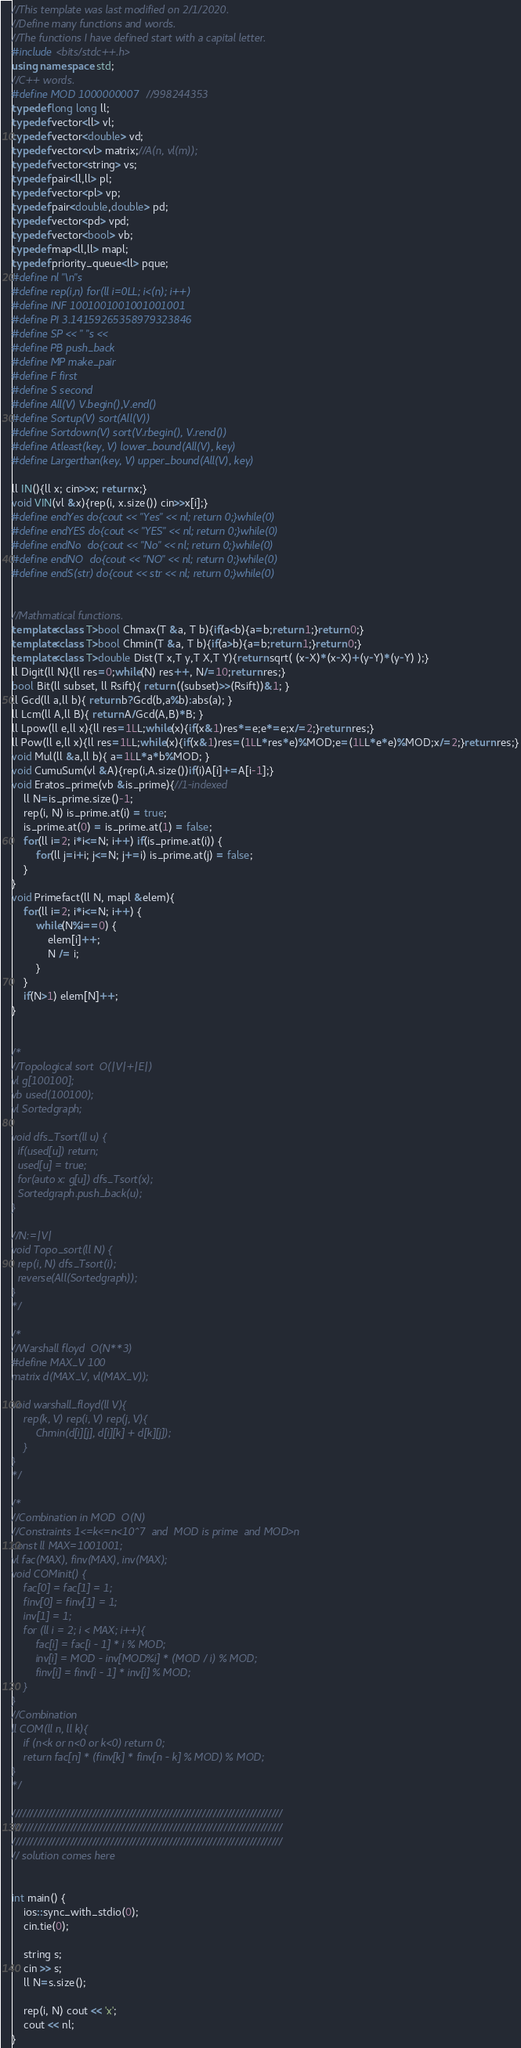<code> <loc_0><loc_0><loc_500><loc_500><_C++_>//This template was last modified on 2/1/2020.
//Define many functions and words.
//The functions I have defined start with a capital letter.
#include <bits/stdc++.h>
using namespace std;
//C++ words.
#define MOD 1000000007 //998244353
typedef long long ll;
typedef vector<ll> vl;
typedef vector<double> vd;
typedef vector<vl> matrix;//A(n, vl(m));
typedef vector<string> vs;
typedef pair<ll,ll> pl;
typedef vector<pl> vp;
typedef pair<double,double> pd;
typedef vector<pd> vpd;
typedef vector<bool> vb;
typedef map<ll,ll> mapl;
typedef priority_queue<ll> pque;
#define nl "\n"s
#define rep(i,n) for(ll i=0LL; i<(n); i++)
#define INF 1001001001001001001
#define PI 3.14159265358979323846
#define SP << " "s <<
#define PB push_back
#define MP make_pair
#define F first
#define S second
#define All(V) V.begin(),V.end()
#define Sortup(V) sort(All(V))
#define Sortdown(V) sort(V.rbegin(), V.rend())
#define Atleast(key, V) lower_bound(All(V), key)
#define Largerthan(key, V) upper_bound(All(V), key)

ll IN(){ll x; cin>>x; return x;}
void VIN(vl &x){rep(i, x.size()) cin>>x[i];}
#define endYes do{cout << "Yes" << nl; return 0;}while(0)
#define endYES do{cout << "YES" << nl; return 0;}while(0)
#define endNo  do{cout << "No" << nl; return 0;}while(0)
#define endNO  do{cout << "NO" << nl; return 0;}while(0)
#define endS(str) do{cout << str << nl; return 0;}while(0)


//Mathmatical functions.
template<class T>bool Chmax(T &a, T b){if(a<b){a=b;return 1;}return 0;}
template<class T>bool Chmin(T &a, T b){if(a>b){a=b;return 1;}return 0;}
template<class T>double Dist(T x,T y,T X,T Y){return sqrt( (x-X)*(x-X)+(y-Y)*(y-Y) );}
ll Digit(ll N){ll res=0;while(N) res++, N/=10;return res;}
bool Bit(ll subset, ll Rsift){ return ((subset)>>(Rsift))&1; }
ll Gcd(ll a,ll b){ return b?Gcd(b,a%b):abs(a); }
ll Lcm(ll A,ll B){ return A/Gcd(A,B)*B; }
ll Lpow(ll e,ll x){ll res=1LL;while(x){if(x&1)res*=e;e*=e;x/=2;}return res;}
ll Pow(ll e,ll x){ll res=1LL;while(x){if(x&1)res=(1LL*res*e)%MOD;e=(1LL*e*e)%MOD;x/=2;}return res;}
void Mul(ll &a,ll b){ a=1LL*a*b%MOD; }
void CumuSum(vl &A){rep(i,A.size())if(i)A[i]+=A[i-1];}
void Eratos_prime(vb &is_prime){//1-indexed
    ll N=is_prime.size()-1;
    rep(i, N) is_prime.at(i) = true;
    is_prime.at(0) = is_prime.at(1) = false;
    for(ll i=2; i*i<=N; i++) if(is_prime.at(i)) {
        for(ll j=i+i; j<=N; j+=i) is_prime.at(j) = false;
    }
}
void Primefact(ll N, mapl &elem){
    for(ll i=2; i*i<=N; i++) {
        while(N%i==0) {
            elem[i]++;
            N /= i;
        }
    }
    if(N>1) elem[N]++;
}


/*
//Topological sort  O(|V|+|E|)
vl g[100100];
vb used(100100);
vl Sortedgraph;

void dfs_Tsort(ll u) {
  if(used[u]) return;
  used[u] = true;
  for(auto x: g[u]) dfs_Tsort(x);
  Sortedgraph.push_back(u);
}

//N:=|V|
void Topo_sort(ll N) {
  rep(i, N) dfs_Tsort(i);
  reverse(All(Sortedgraph));
}
*/

/*
//Warshall floyd  O(N**3)
#define MAX_V 100
matrix d(MAX_V, vl(MAX_V));

void warshall_floyd(ll V){
    rep(k, V) rep(i, V) rep(j, V){
        Chmin(d[i][j], d[i][k] + d[k][j]);
    }
}
*/

/*
//Combination in MOD  O(N)
//Constraints 1<=k<=n<10^7  and  MOD is prime  and MOD>n
const ll MAX=1001001;
vl fac(MAX), finv(MAX), inv(MAX);
void COMinit() {
    fac[0] = fac[1] = 1;
    finv[0] = finv[1] = 1;
    inv[1] = 1;
    for (ll i = 2; i < MAX; i++){
        fac[i] = fac[i - 1] * i % MOD;
        inv[i] = MOD - inv[MOD%i] * (MOD / i) % MOD;
        finv[i] = finv[i - 1] * inv[i] % MOD;
    }
}
//Combination
ll COM(ll n, ll k){
    if (n<k or n<0 or k<0) return 0;
    return fac[n] * (finv[k] * finv[n - k] % MOD) % MOD;
}
*/

//////////////////////////////////////////////////////////////////////////
//////////////////////////////////////////////////////////////////////////
//////////////////////////////////////////////////////////////////////////
// solution comes here


int main() {
    ios::sync_with_stdio(0);
    cin.tie(0);

    string s;
    cin >> s;
    ll N=s.size();

    rep(i, N) cout << 'x';
    cout << nl;
}</code> 